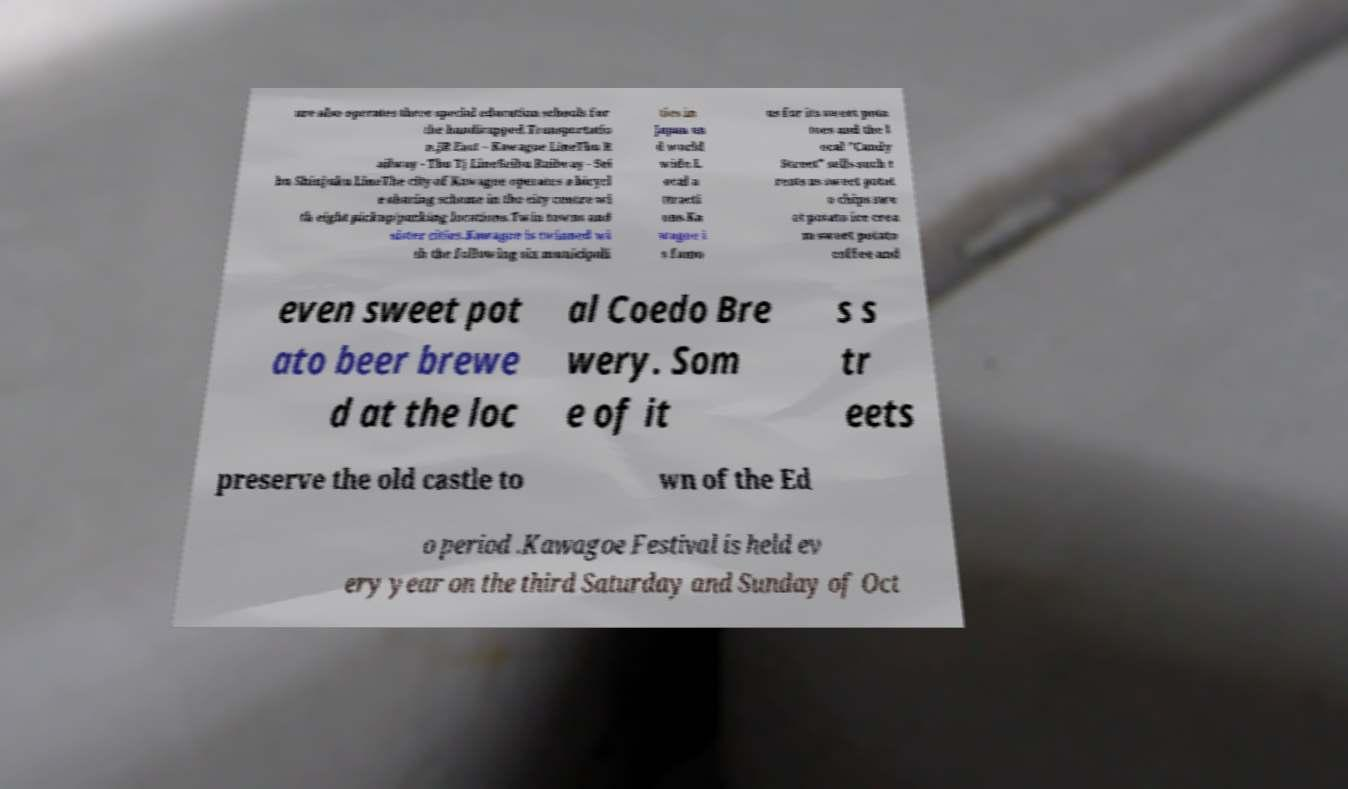Could you extract and type out the text from this image? ure also operates three special education schools for the handicapped.Transportatio n.JR East – Kawagoe LineTbu R ailway - Tbu Tj LineSeibu Railway - Sei bu Shinjuku LineThe city of Kawagoe operates a bicycl e sharing scheme in the city centre wi th eight pickup/parking locations.Twin towns and sister cities.Kawagoe is twinned wi th the following six municipali ties in Japan an d world wide.L ocal a ttracti ons.Ka wagoe i s famo us for its sweet pota toes and the l ocal "Candy Street" sells such t reats as sweet potat o chips swe et potato ice crea m sweet potato coffee and even sweet pot ato beer brewe d at the loc al Coedo Bre wery. Som e of it s s tr eets preserve the old castle to wn of the Ed o period .Kawagoe Festival is held ev ery year on the third Saturday and Sunday of Oct 